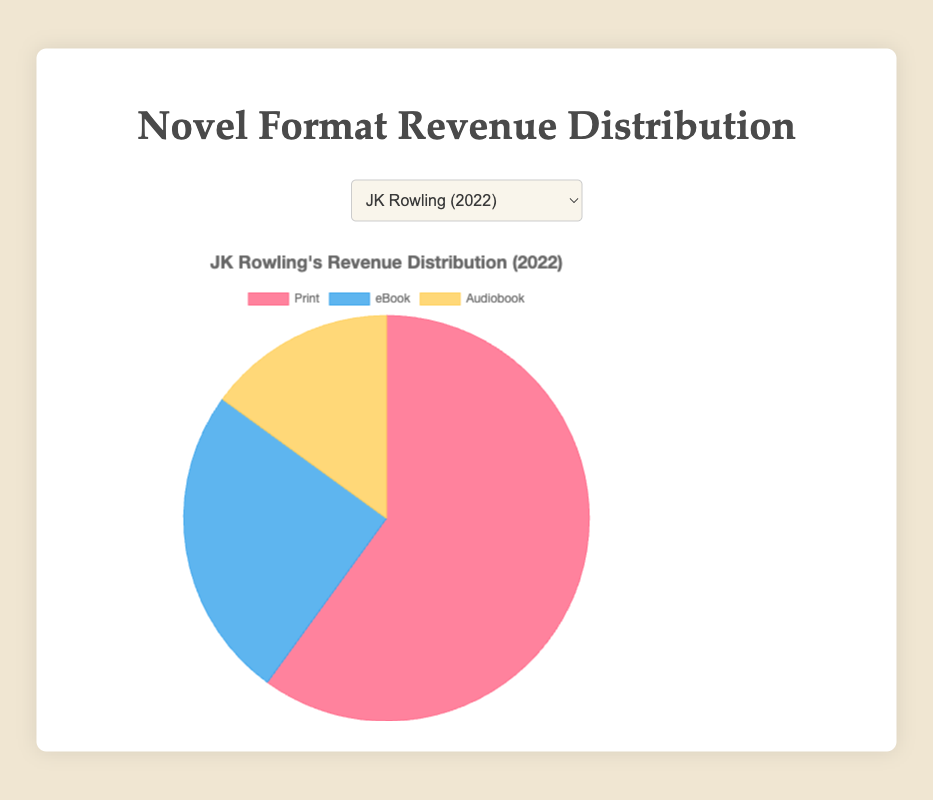What percentage of revenue does the Print format contribute for Stephen King? Stephen King's Print format revenue is shown as a section of the pie chart. From the data, Print format contributes 55% to Stephen King's total revenue.
Answer: 55% Which author has the highest Print revenue contribution in 2021? By observing the data and the pie chart, Agatha Christie has the highest Print revenue contribution in 2021 with 70%.
Answer: Agatha Christie How does George R.R. Martin's eBook revenue contribution compare to JK Rowling's eBook revenue contribution in 2022? Compare the eBook sections of the pie charts for both authors. George R.R. Martin has a 40% eBook revenue contribution while JK Rowling has 25%. George R.R. Martin's eBook contribution is higher.
Answer: George R.R. Martin Compare the total percentages of Print and Audiobook revenues for Dan Brown in 2021. Add the percentages of Print (65%) and Audiobook (10%) for Dan Brown. 65% + 10% = 75%.
Answer: 75% What is the combined percentage of Audiobook revenues for all authors in 2022? Sum up the Audiobook revenue percentages for all authors in 2022: JK Rowling (15%), Stephen King (15%), and George R.R. Martin (10%). 15% + 15% + 10% = 40%.
Answer: 40% What format contributes the least to Margaret Atwood's total revenue? Refer to the pie chart for Margaret Atwood's revenue. The segment representing the smallest percentage is the Audiobook, which is 15%.
Answer: Audiobook Which author has the closest distribution of revenue among all three formats in 2022? Compare the distribution of percentages in the pie charts. George R.R. Martin has the most balanced distribution with Print (50%), eBook (40%), and Audiobook (10%).
Answer: George R.R. Martin What is the percentage difference between Agatha Christie’s Print revenue and her eBook revenue? Subtract Agatha Christie’s eBook revenue percentage from her Print revenue percentage: 70% - 20% = 50%.
Answer: 50% Calculate the average eBook revenue contribution for the authors in 2021. Sum up the eBook revenue percentages for all three authors in 2021 (20% for Agatha Christie, 25% for Dan Brown, 30% for Margaret Atwood) and divide by 3. (20% + 25% + 30%) / 3 = 25%.
Answer: 25% What is the most significant revenue source for JK Rowling? By looking at the pie chart for JK Rowling, the Print segment takes up the largest portion at 60%.
Answer: Print 